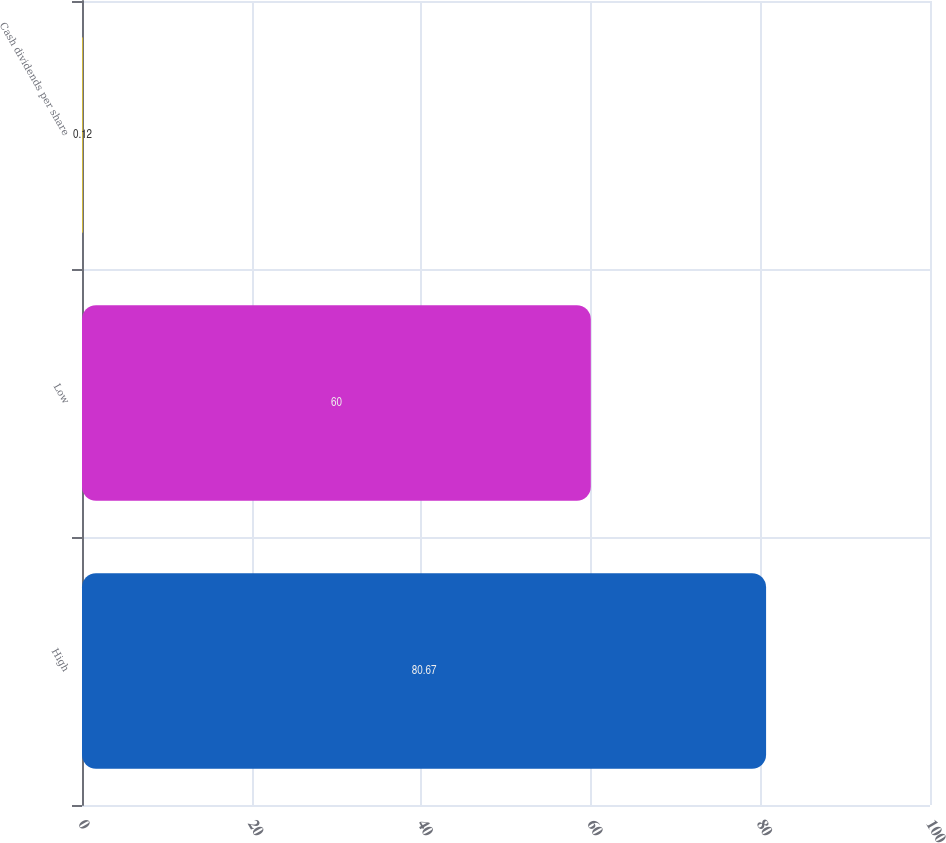Convert chart to OTSL. <chart><loc_0><loc_0><loc_500><loc_500><bar_chart><fcel>High<fcel>Low<fcel>Cash dividends per share<nl><fcel>80.67<fcel>60<fcel>0.12<nl></chart> 